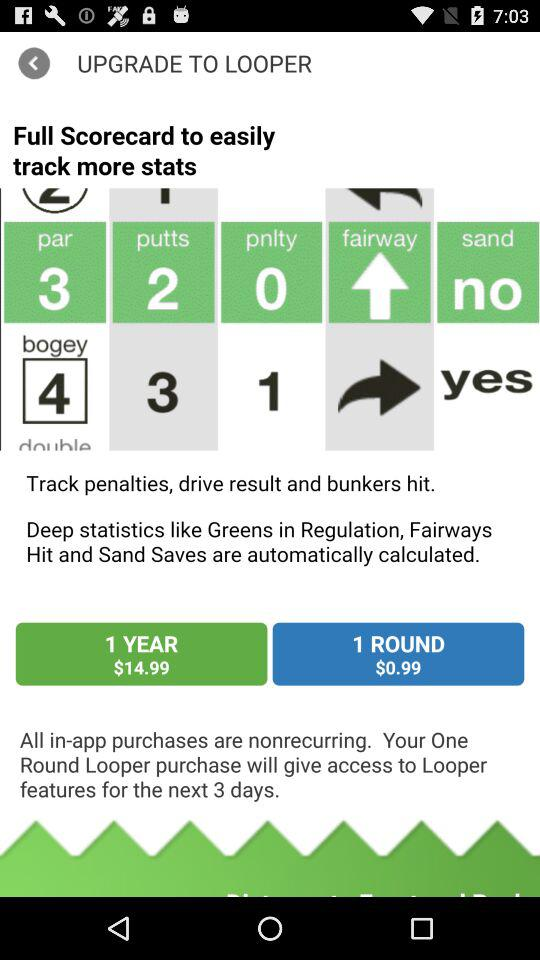For how many days will a user get access with a single round purchase? A user will get access for the next 3 days. 